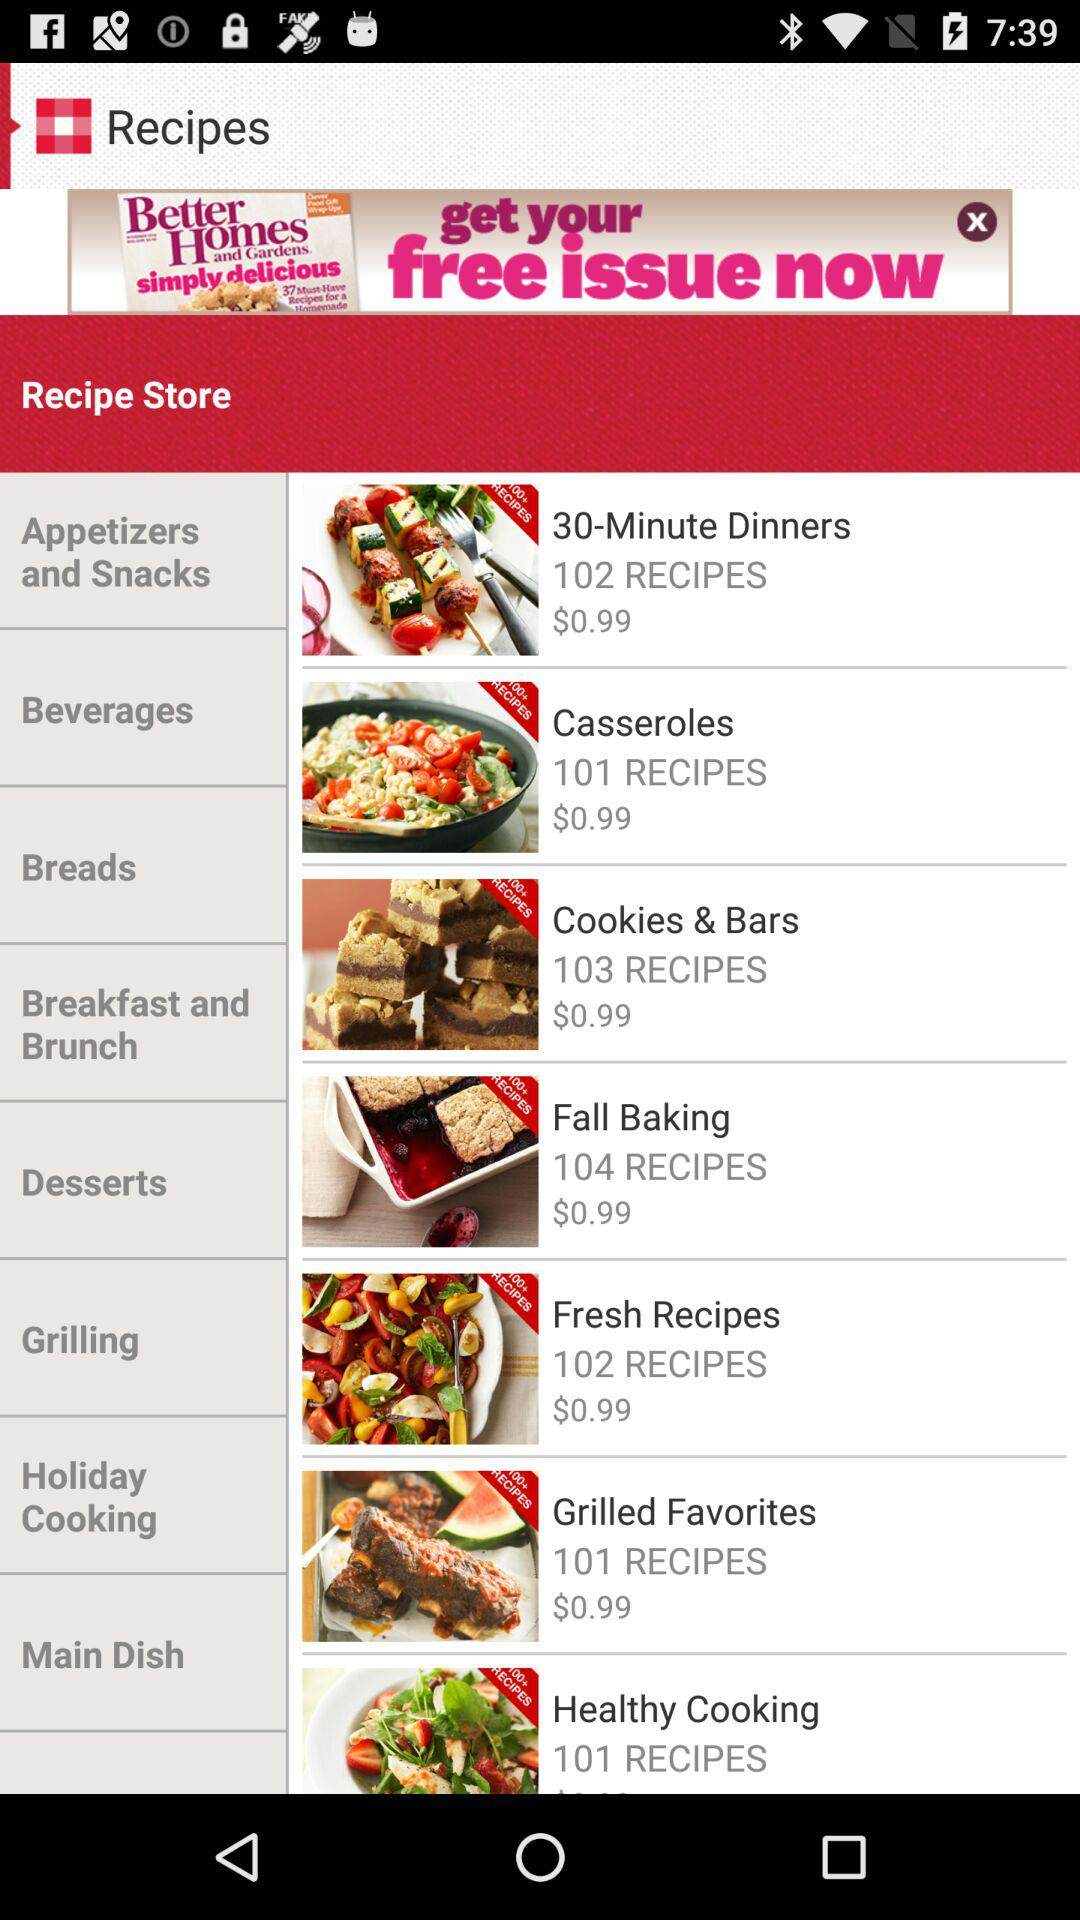How many more recipes are there in the Grilling category than the Holiday Cooking category?
Answer the question using a single word or phrase. 1 